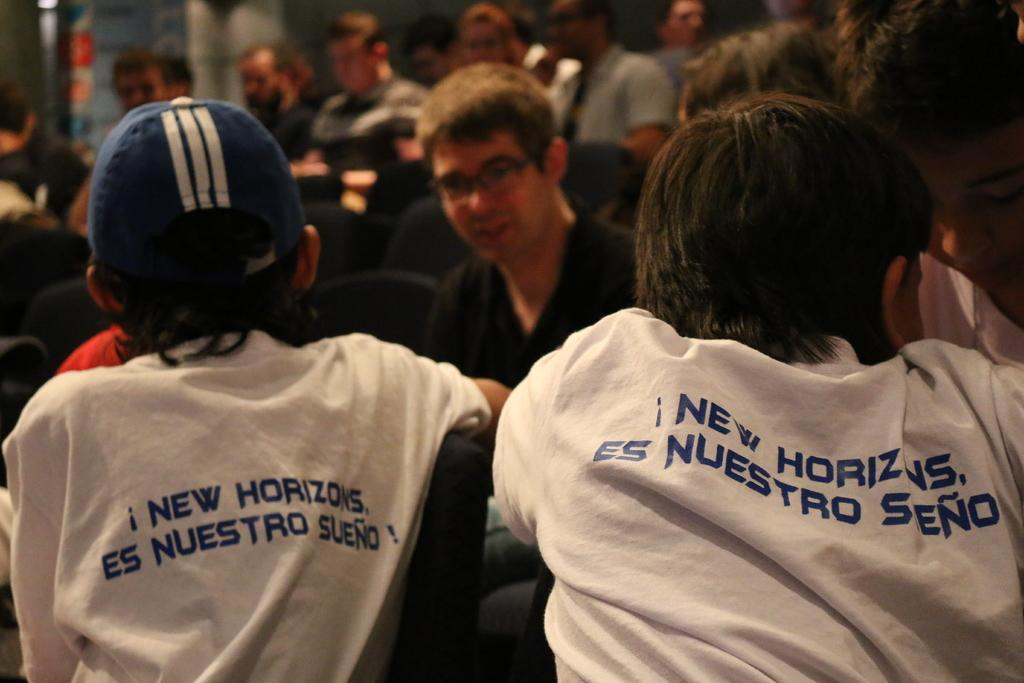How many people are in the image? There are many persons in the image. What are the persons doing in the image? The persons are sitting on chairs. What type of bone is being used by the beginner fireman in the image? There is no bone, beginner, or fireman present in the image. 